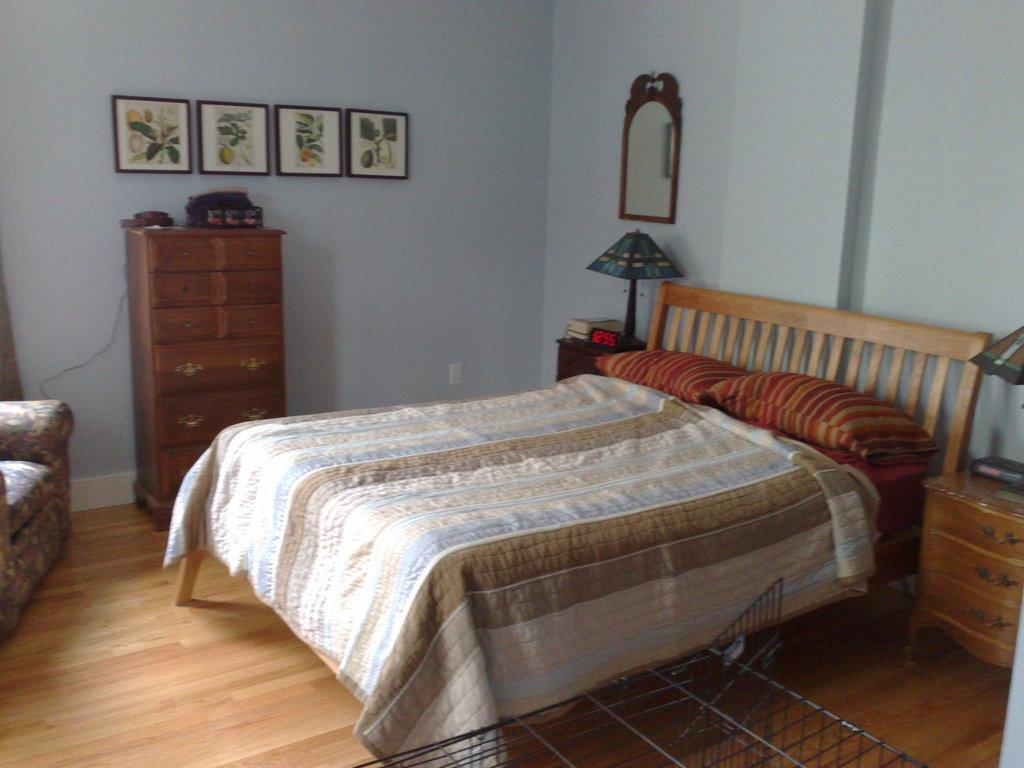What type of objects can be seen in the image? There are photo frames, cupboards, a bed, pillows, a mirror, and a chair in the image. What type of furniture is present in the image? The furniture in the image includes a bed, a chair, and cupboards. What is the purpose of the mirror in the image? The mirror in the image is likely used for personal grooming or to create the illusion of more space. What is the background of the image? There is a wall in the image. What type of discussion is taking place in the image? There is no discussion taking place in the image; it is a still image of various objects and furniture. Can you see any servants in the image? There are no servants present in the image. 